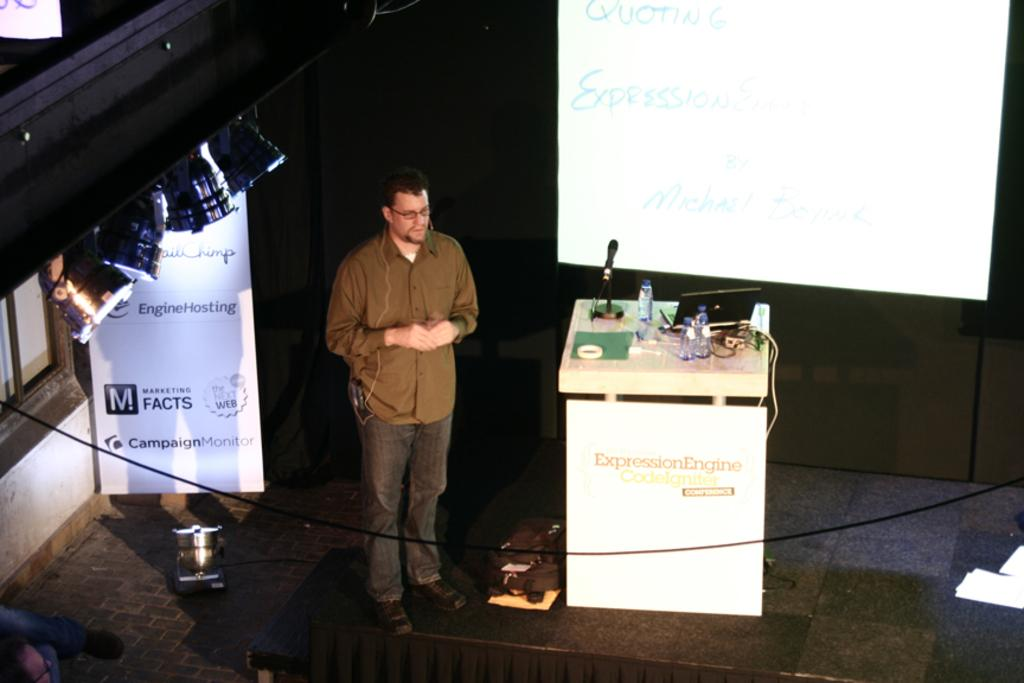What is the man in the image doing? The man is standing on a stage. What is located beside the man on the stage? There is a banner and a screen beside the man. What can be seen in the image that provides illumination? There are lights in the image. What is on the podium in the image? There are bottles, a microphone, and a laptop on the podium. What type of toys can be seen scattered around the stage in the image? There are no toys present in the image; it features a man standing on a stage with a banner, screen, lights, and a podium. 